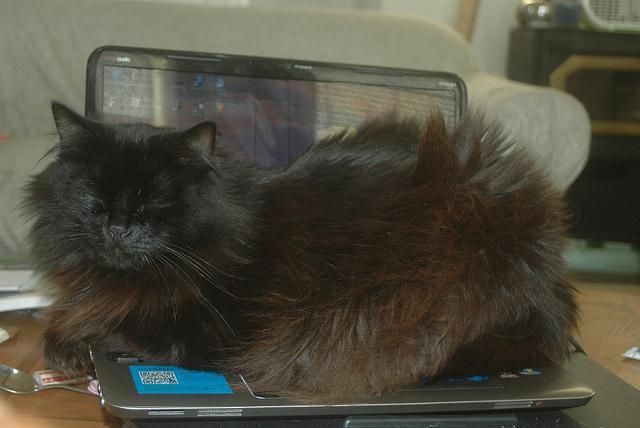How many cats can you see?
Give a very brief answer. 1. How many motorcycles are there?
Give a very brief answer. 0. 